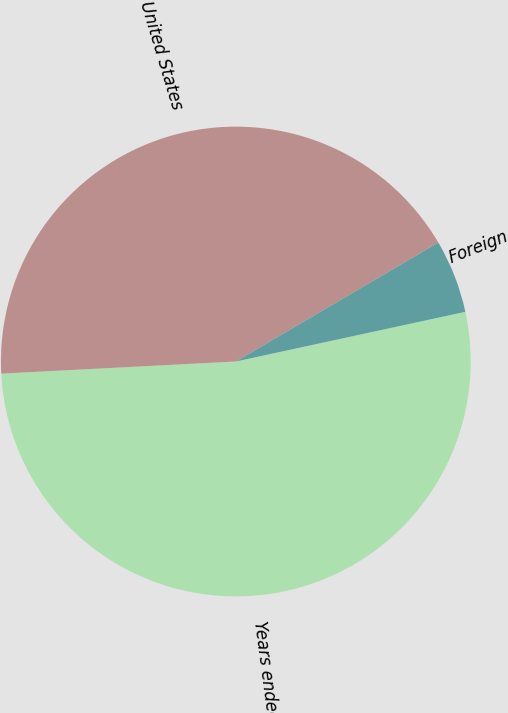<chart> <loc_0><loc_0><loc_500><loc_500><pie_chart><fcel>Years ended June 30<fcel>United States<fcel>Foreign<nl><fcel>52.57%<fcel>42.37%<fcel>5.06%<nl></chart> 